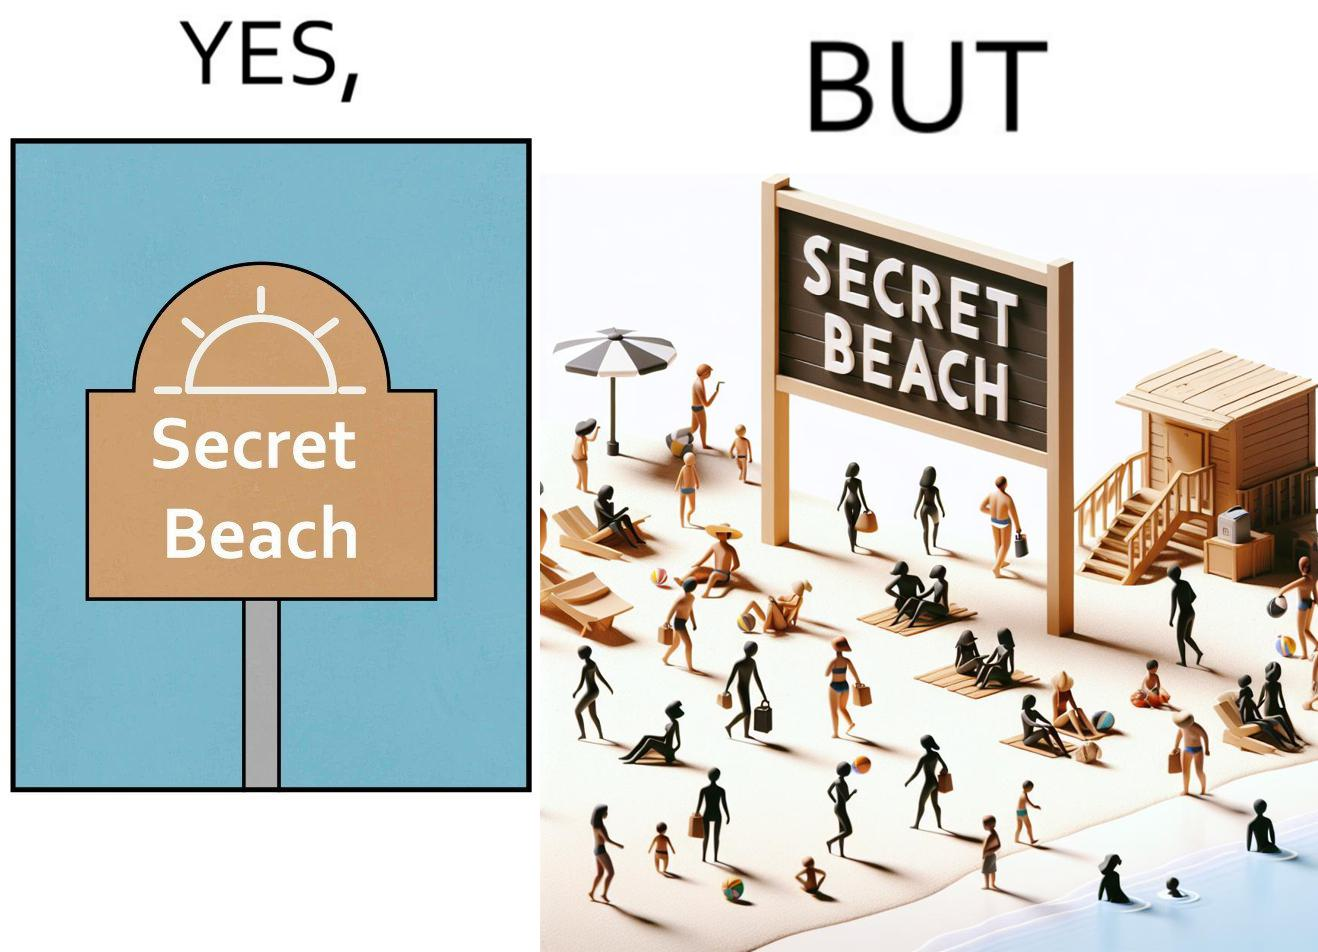Is there satirical content in this image? Yes, this image is satirical. 